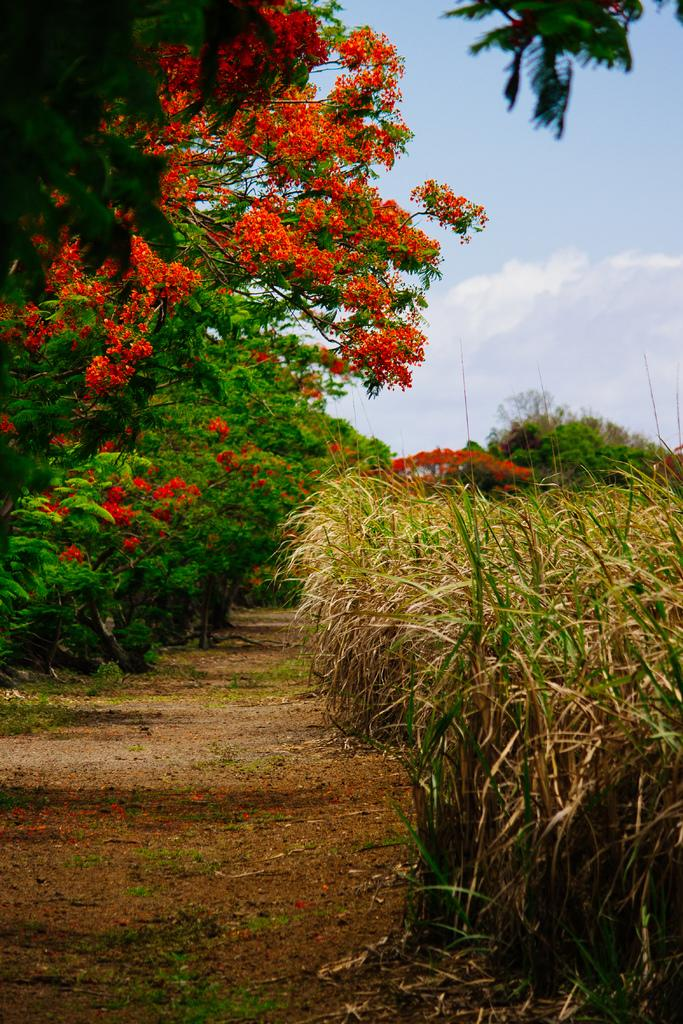What type of vegetation can be seen in the image? There are trees in the image. What color are the flowers in the image? The flowers in the image are orange in color. What type of ground cover is visible in the image? There is grass visible in the image. What colors can be seen in the sky in the image? The sky is blue and white in color. Can you tell me what time the friend is coming in the image? There is no friend or indication of time in the image; it only features trees, flowers, grass, and the sky. What type of jar is visible in the image? There is no jar present in the image. 